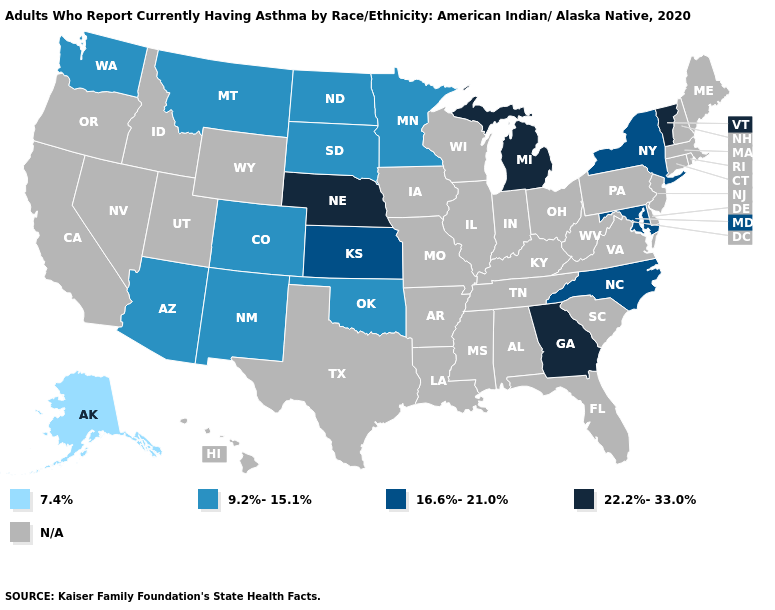What is the highest value in the Northeast ?
Keep it brief. 22.2%-33.0%. Among the states that border North Carolina , which have the lowest value?
Quick response, please. Georgia. Does Vermont have the lowest value in the Northeast?
Keep it brief. No. What is the lowest value in states that border Montana?
Answer briefly. 9.2%-15.1%. Which states hav the highest value in the Northeast?
Short answer required. Vermont. Is the legend a continuous bar?
Short answer required. No. What is the lowest value in states that border Kansas?
Be succinct. 9.2%-15.1%. Which states have the lowest value in the MidWest?
Be succinct. Minnesota, North Dakota, South Dakota. What is the value of Montana?
Short answer required. 9.2%-15.1%. What is the highest value in states that border Tennessee?
Write a very short answer. 22.2%-33.0%. Which states hav the highest value in the West?
Keep it brief. Arizona, Colorado, Montana, New Mexico, Washington. Which states have the highest value in the USA?
Give a very brief answer. Georgia, Michigan, Nebraska, Vermont. What is the highest value in the MidWest ?
Keep it brief. 22.2%-33.0%. 